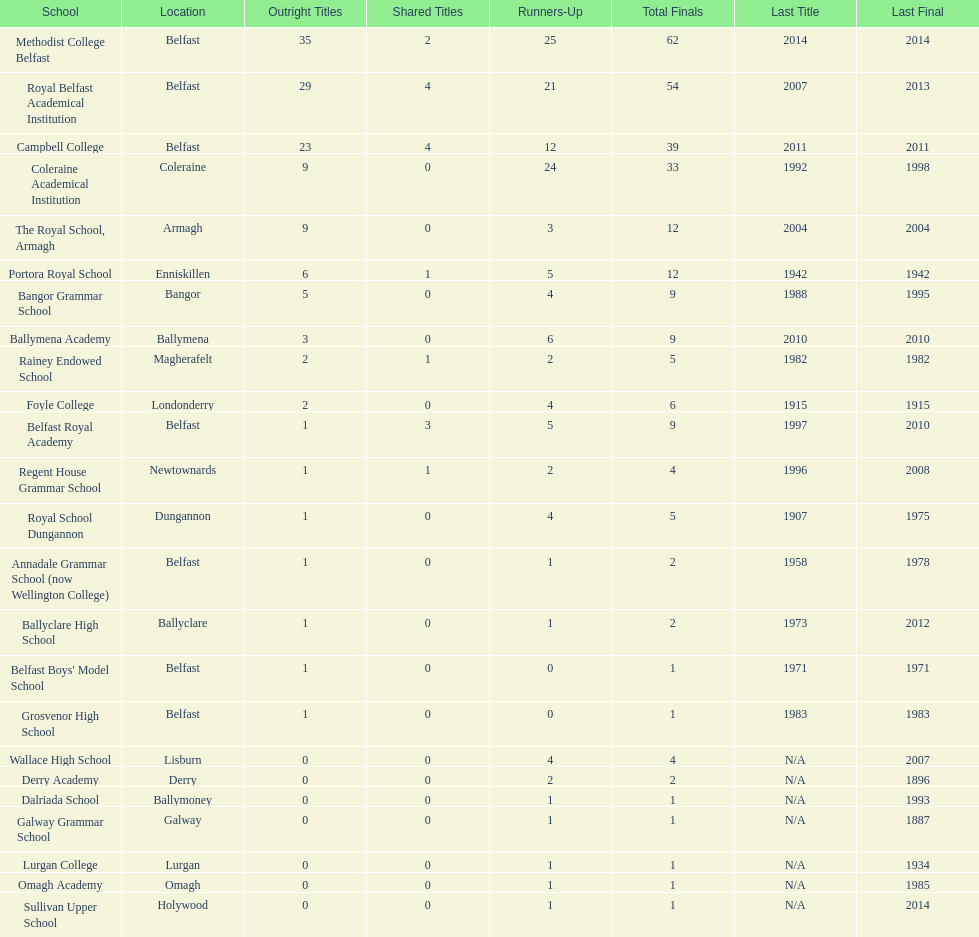What's the overall number of finals held at foyle college? 6. 